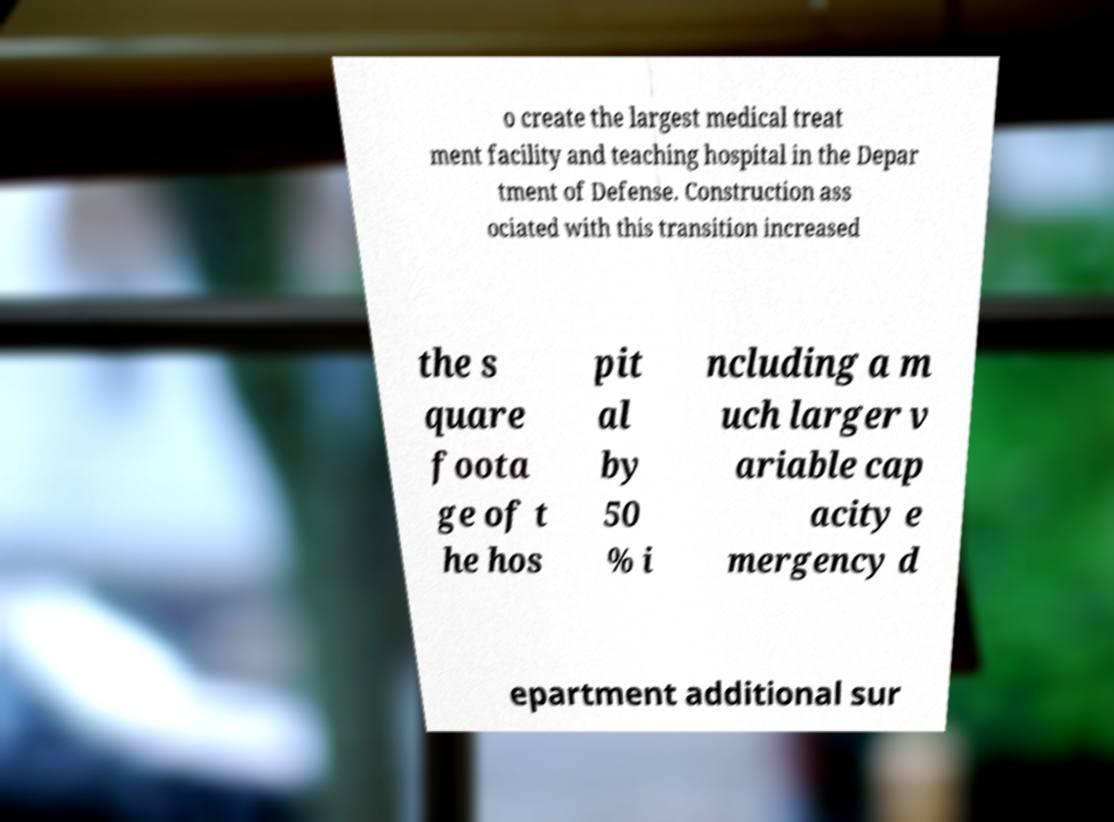Could you assist in decoding the text presented in this image and type it out clearly? o create the largest medical treat ment facility and teaching hospital in the Depar tment of Defense. Construction ass ociated with this transition increased the s quare foota ge of t he hos pit al by 50 % i ncluding a m uch larger v ariable cap acity e mergency d epartment additional sur 